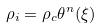Convert formula to latex. <formula><loc_0><loc_0><loc_500><loc_500>\rho _ { i } = \rho _ { c } \theta ^ { n } ( \xi )</formula> 